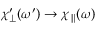<formula> <loc_0><loc_0><loc_500><loc_500>{ \chi _ { \perp } ^ { \prime } } ( \omega ^ { \prime } ) \rightarrow \chi _ { \| } ( \omega )</formula> 